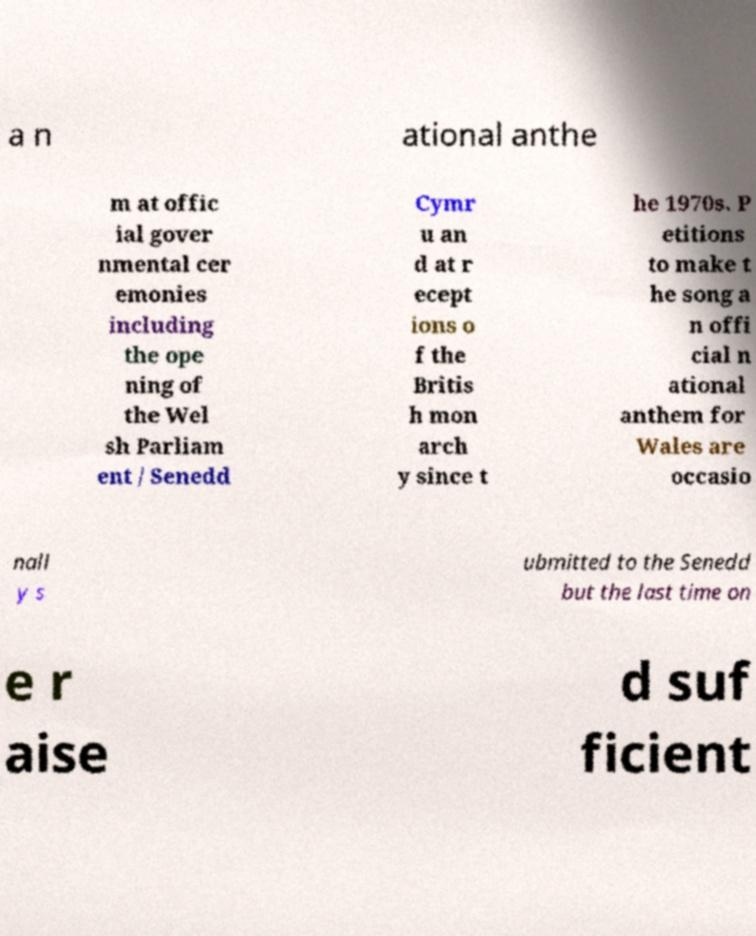Please read and relay the text visible in this image. What does it say? a n ational anthe m at offic ial gover nmental cer emonies including the ope ning of the Wel sh Parliam ent / Senedd Cymr u an d at r ecept ions o f the Britis h mon arch y since t he 1970s. P etitions to make t he song a n offi cial n ational anthem for Wales are occasio nall y s ubmitted to the Senedd but the last time on e r aise d suf ficient 